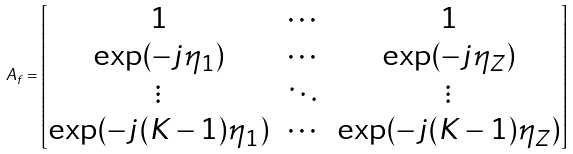<formula> <loc_0><loc_0><loc_500><loc_500>A _ { f } = \begin{bmatrix} 1 & \cdots & 1 \\ \exp ( - j \eta _ { 1 } ) & \cdots & \exp ( - j \eta _ { Z } ) \\ \vdots & \ddots & \vdots \\ \exp ( - j ( K - 1 ) \eta _ { 1 } ) & \cdots & \exp ( - j ( K - 1 ) \eta _ { Z } ) \end{bmatrix}</formula> 